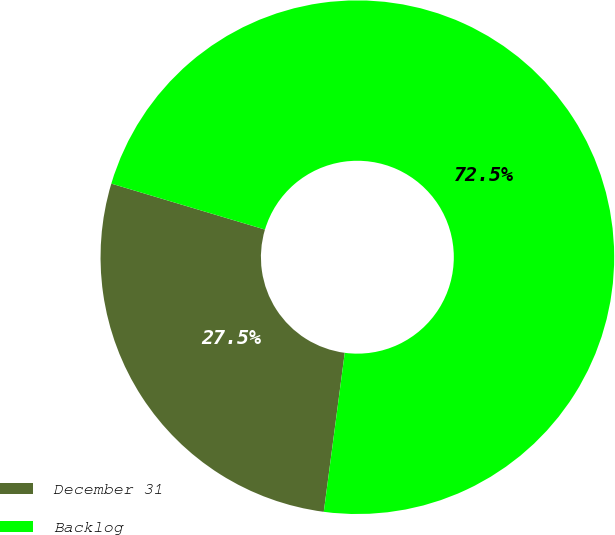<chart> <loc_0><loc_0><loc_500><loc_500><pie_chart><fcel>December 31<fcel>Backlog<nl><fcel>27.54%<fcel>72.46%<nl></chart> 